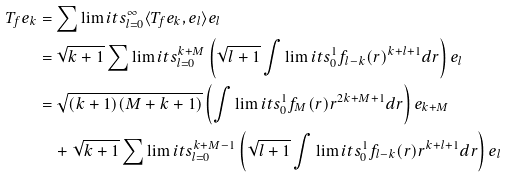Convert formula to latex. <formula><loc_0><loc_0><loc_500><loc_500>T _ { f } e _ { k } & = \sum \lim i t s _ { l = 0 } ^ { \infty } \langle T _ { f } e _ { k } , e _ { l } \rangle e _ { l } \\ & = \sqrt { k + 1 } \sum \lim i t s _ { l = 0 } ^ { k + M } \left ( \sqrt { l + 1 } \int \lim i t s _ { 0 } ^ { 1 } f _ { l - k } ( r ) ^ { k + l + 1 } d r \right ) e _ { l } \\ & = \sqrt { ( k + 1 ) ( M + k + 1 ) } \left ( \int \lim i t s _ { 0 } ^ { 1 } f _ { M } ( r ) r ^ { 2 k + M + 1 } d r \right ) e _ { k + M } \\ & \quad + \sqrt { k + 1 } \sum \lim i t s _ { l = 0 } ^ { k + M - 1 } \left ( \sqrt { l + 1 } \int \lim i t s _ { 0 } ^ { 1 } f _ { l - k } ( r ) r ^ { k + l + 1 } d r \right ) e _ { l }</formula> 